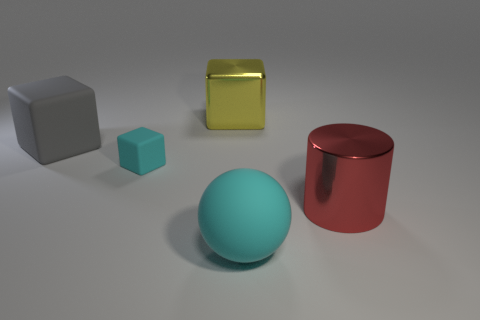What colors are the objects presented in the image? The image showcases objects of various colors: there's a gray large cube, a small turquoise cube, a gold matte box, a large red metallic cylinder, and a large sphere that appears to be light blue or cyan. 